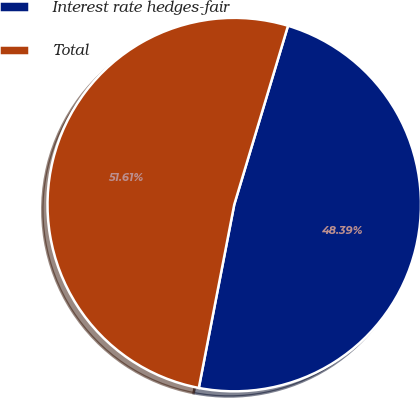Convert chart to OTSL. <chart><loc_0><loc_0><loc_500><loc_500><pie_chart><fcel>Interest rate hedges-fair<fcel>Total<nl><fcel>48.39%<fcel>51.61%<nl></chart> 